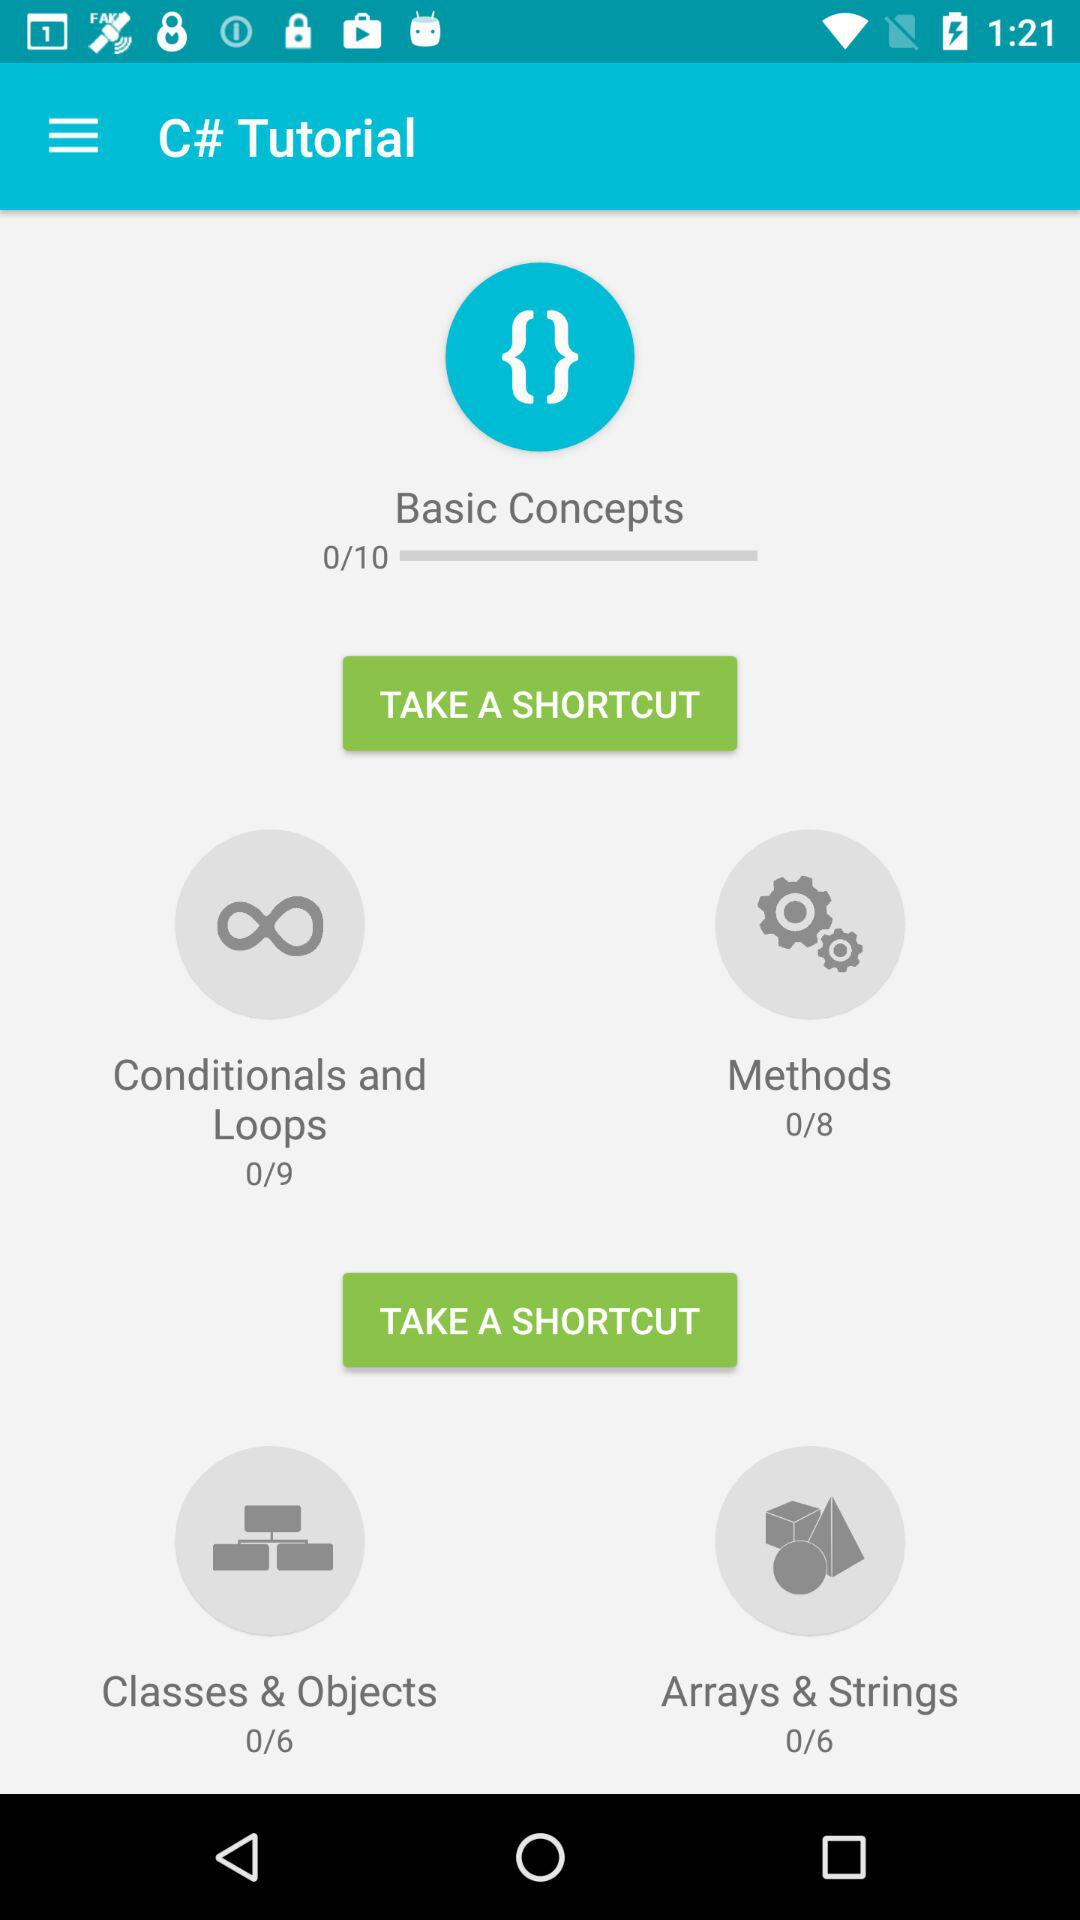How many more lessons are there in the Methods section than the Conditionals and Loops section?
Answer the question using a single word or phrase. 1 